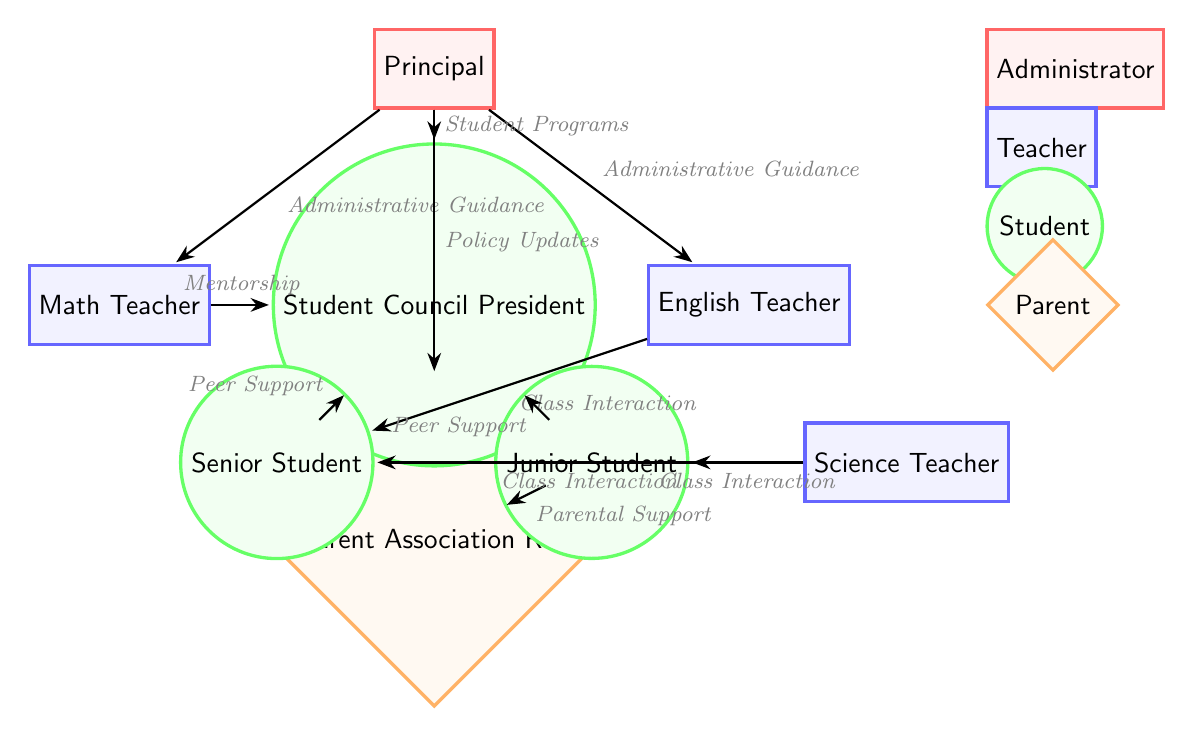What is the title of the diagram? The title is not explicitly stated in the diagram, but it represents "Patterns of communication within school communities."
Answer: Patterns of communication within school communities How many teacher nodes are in the diagram? The diagram contains three teacher nodes: Math Teacher, English Teacher, and Science Teacher.
Answer: 3 What type of relationship does the Principal have with the Parent Association Rep? The relationship is labeled as "Policy Updates," representing an administrative communication.
Answer: Policy Updates Which node has the most connections? The Student Council President has connections to both the Math Teacher (Mentorship) and the Parent Association Rep (Parental Support), making it central to many interactions.
Answer: Student Council President What is the relationship type between the Senior Student and the English Teacher? There is no direct relationship indicated between the Senior Student and the English Teacher in the diagram.
Answer: None Which node is situated at the top of the diagram? The top node in the diagram is the Principal, who serves as the central administrator in this communication network.
Answer: Principal What type of node is the Student Council President? The Student Council President is classified as a student node, as indicated by its circular shape and green color.
Answer: Student Which teacher interacts with the Junior Student? The Science Teacher has a "Class Interaction" relationship with the Junior Student, indicating a participatory academic relationship.
Answer: Science Teacher How many edges connect to the Administrator node? The Administrator (Principal) node is connected to four edges labeled with various types of interactions, such as "Administrative Guidance" and "Student Programs."
Answer: 4 What is the connection between the Senior Student and the Student Council President? The connection is identified as "Peer Support," indicating a support system among peers in the school setting.
Answer: Peer Support 